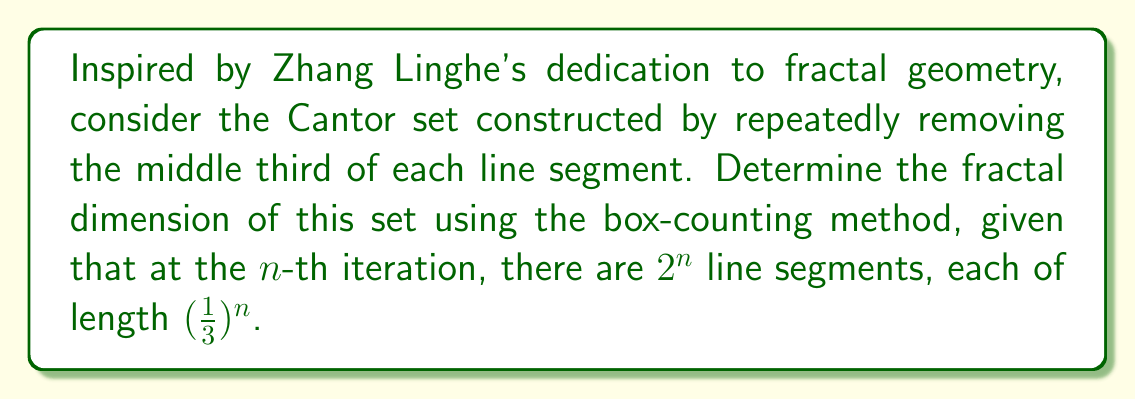Can you solve this math problem? Let's approach this step-by-step using the box-counting method:

1) In the box-counting method, we cover the set with boxes of size $\epsilon$ and count how many boxes $N(\epsilon)$ are needed to cover the set.

2) The fractal dimension $D$ is given by:

   $$D = \lim_{\epsilon \to 0} \frac{\log N(\epsilon)}{\log(1/\epsilon)}$$

3) For the Cantor set, at the $n$-th iteration:
   - The length of each segment is $\epsilon = (\frac{1}{3})^n$
   - The number of segments (boxes) is $N(\epsilon) = 2^n$

4) We can rewrite $n$ in terms of $\epsilon$:
   
   $$(\frac{1}{3})^n = \epsilon$$
   $$n = \frac{\log \epsilon}{\log(1/3)}$$

5) Now, let's substitute this into our expression for $N(\epsilon)$:

   $$N(\epsilon) = 2^n = 2^{\frac{\log \epsilon}{\log(1/3)}} = \epsilon^{\frac{\log 2}{\log(1/3)}}$$

6) Taking the logarithm of both sides:

   $$\log N(\epsilon) = \frac{\log 2}{\log(1/3)} \log \epsilon$$

7) Now we can calculate the fractal dimension:

   $$D = \lim_{\epsilon \to 0} \frac{\log N(\epsilon)}{\log(1/\epsilon)} = \lim_{\epsilon \to 0} \frac{\frac{\log 2}{\log(1/3)} \log \epsilon}{-\log \epsilon} = \frac{\log 2}{\log 3}$$

8) Calculating this value:

   $$D = \frac{\log 2}{\log 3} \approx 0.6309$$
Answer: $\frac{\log 2}{\log 3}$ 